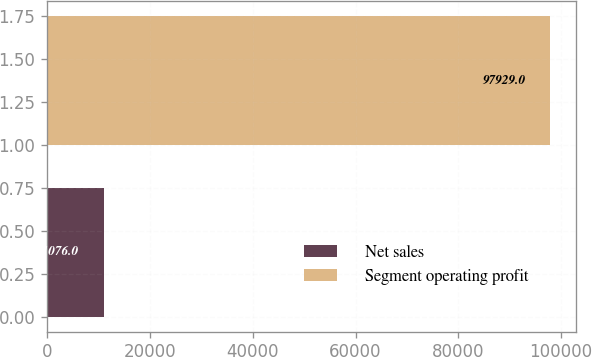<chart> <loc_0><loc_0><loc_500><loc_500><bar_chart><fcel>Net sales<fcel>Segment operating profit<nl><fcel>11076<fcel>97929<nl></chart> 